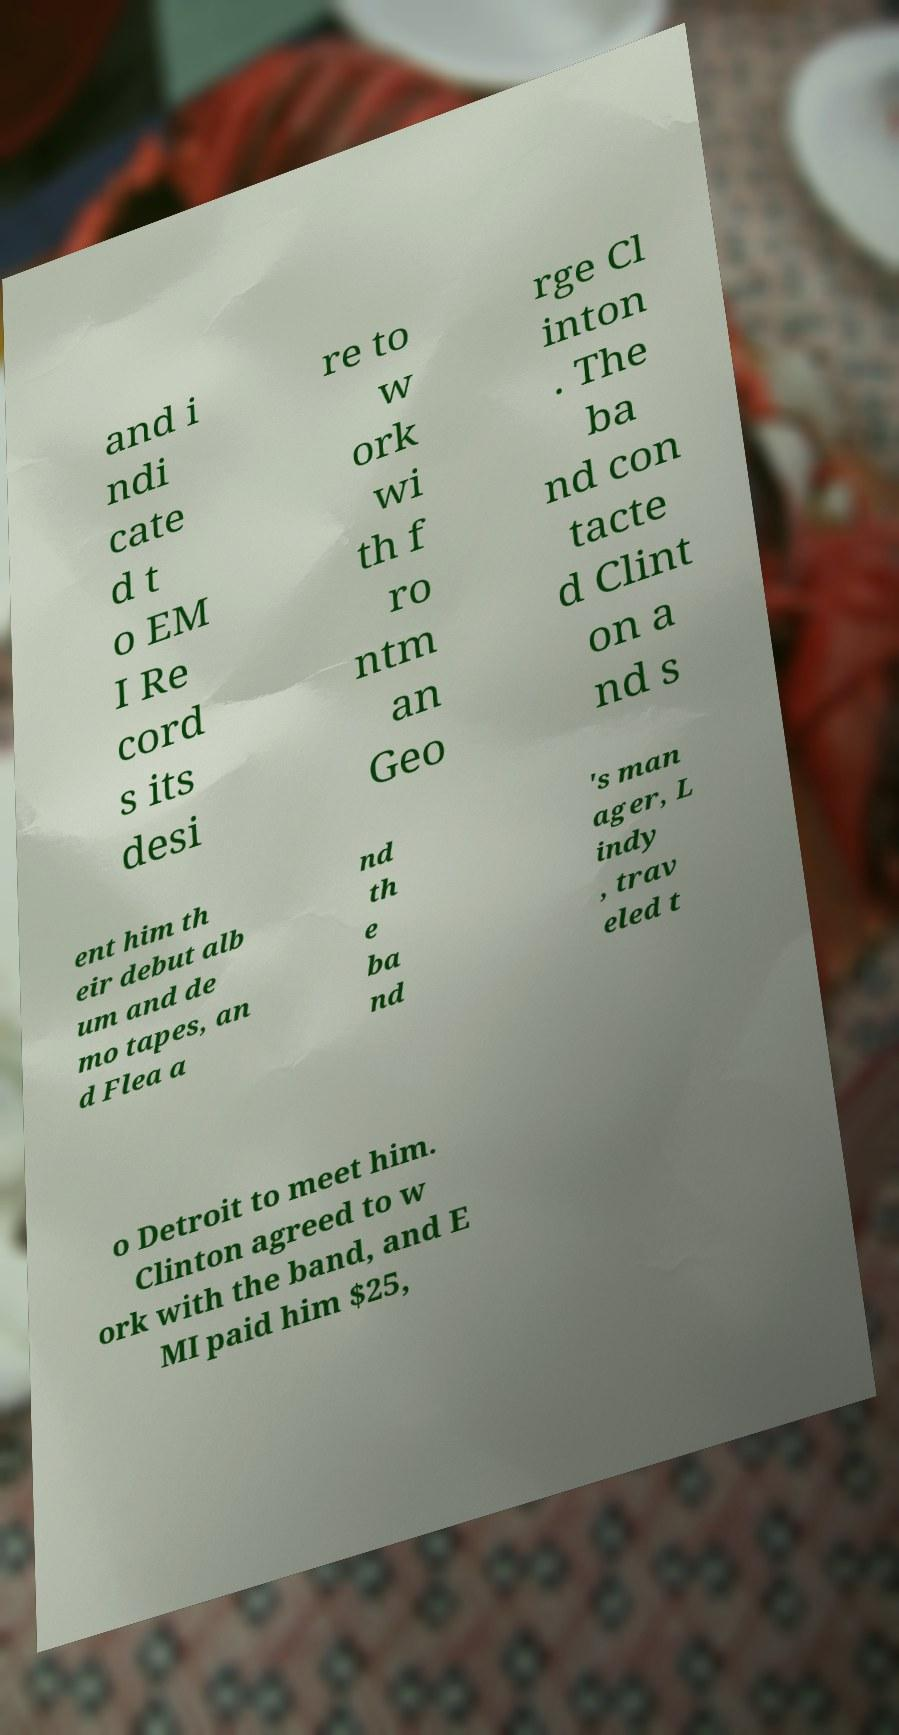Could you extract and type out the text from this image? and i ndi cate d t o EM I Re cord s its desi re to w ork wi th f ro ntm an Geo rge Cl inton . The ba nd con tacte d Clint on a nd s ent him th eir debut alb um and de mo tapes, an d Flea a nd th e ba nd 's man ager, L indy , trav eled t o Detroit to meet him. Clinton agreed to w ork with the band, and E MI paid him $25, 